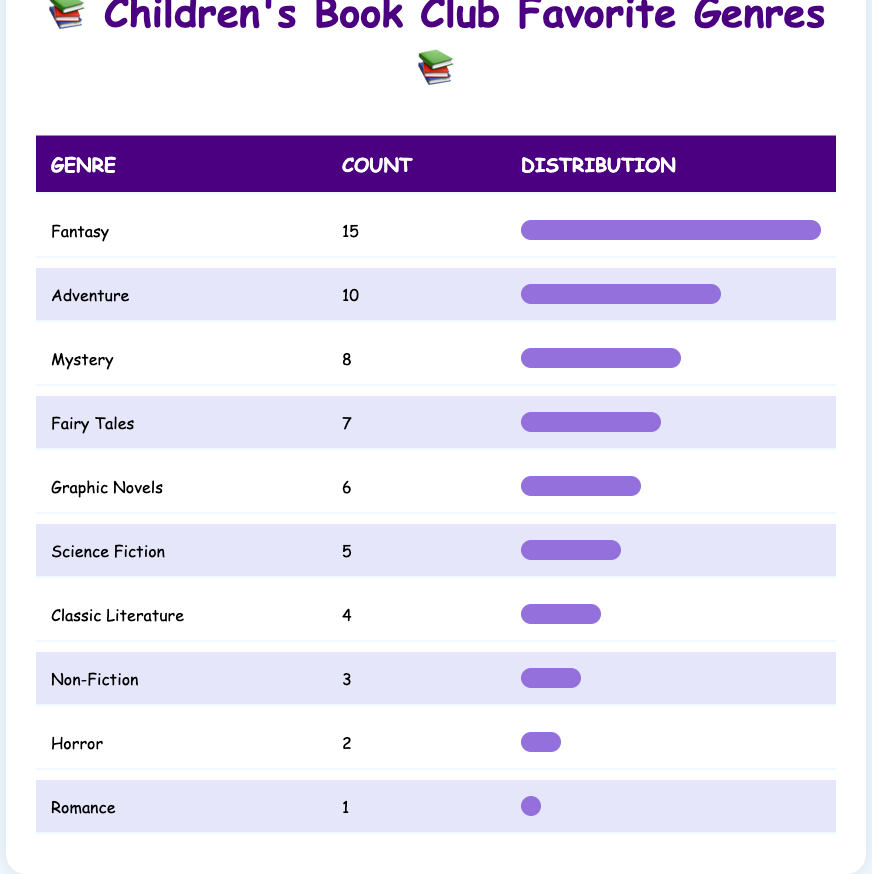What genre has the highest count? The table lists each genre alongside its count. The genre with the highest count is "Fantasy," which has a count of 15.
Answer: Fantasy How many children favor the "Adventure" genre? According to the table, the count for the "Adventure" genre is 10.
Answer: 10 Is the "Horror" genre favored by more than 3 children? The table shows the count for the "Horror" genre is 2. Since 2 is not greater than 3, the answer is no.
Answer: No What is the total count of children who participated in the survey? To find the total, we need to sum all the counts: 15 + 10 + 8 + 5 + 7 + 3 + 6 + 2 + 1 + 4 = 57.
Answer: 57 Which genre has the lowest count, and how many children favor it? The table indicates that the "Romance" genre has the lowest count of 1.
Answer: Romance, 1 What is the difference between the counts of "Graphic Novels" and "Mystery"? The count for "Graphic Novels" is 6, and for "Mystery," it is 8. The difference is 8 - 6 = 2.
Answer: 2 What percentage of children favored "Fairy Tales" compared to "Fantasy"? The count for "Fairy Tales" is 7 and for "Fantasy" is 15. To get the percentage, we calculate (7 / 15) * 100 = 46.67%.
Answer: 46.67% Are more children interested in "Science Fiction" than "Non-Fiction"? "Science Fiction" has a count of 5 and "Non-Fiction" has a count of 3. Since 5 is greater than 3, the answer is yes.
Answer: Yes What genre has a count closest to the average count of all genres? The total count is 57 and there are 10 genres, so the average is 57 / 10 = 5.7. The genres closest to this average are "Science Fiction" with a count of 5 and "Non-Fiction" with a count of 3 (which is lower) and "Graphic Novels" with 6 (which is higher).
Answer: Science Fiction and Graphic Novels What is the observation regarding the relative popularity of "Romance" compared to "Fantasy"? The count for "Romance" is 1, while "Fantasy" has a significantly higher count of 15. This demonstrates that "Romance" is much less popular than "Fantasy" among children.
Answer: Romance is much less popular than Fantasy 